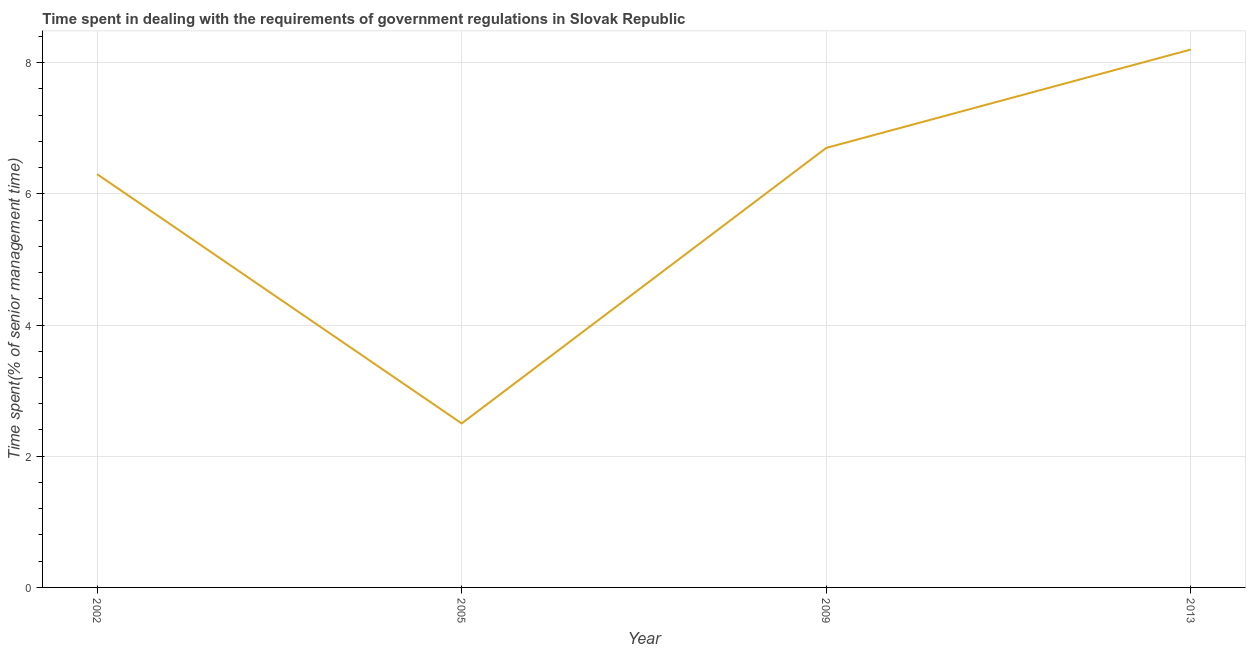What is the time spent in dealing with government regulations in 2002?
Provide a succinct answer. 6.3. Across all years, what is the maximum time spent in dealing with government regulations?
Provide a succinct answer. 8.2. What is the sum of the time spent in dealing with government regulations?
Make the answer very short. 23.7. What is the difference between the time spent in dealing with government regulations in 2002 and 2009?
Your answer should be very brief. -0.4. What is the average time spent in dealing with government regulations per year?
Keep it short and to the point. 5.92. What is the median time spent in dealing with government regulations?
Make the answer very short. 6.5. In how many years, is the time spent in dealing with government regulations greater than 0.8 %?
Give a very brief answer. 4. Do a majority of the years between 2013 and 2002 (inclusive) have time spent in dealing with government regulations greater than 2.4 %?
Provide a succinct answer. Yes. What is the ratio of the time spent in dealing with government regulations in 2002 to that in 2005?
Give a very brief answer. 2.52. Is the time spent in dealing with government regulations in 2005 less than that in 2009?
Make the answer very short. Yes. Is the difference between the time spent in dealing with government regulations in 2005 and 2009 greater than the difference between any two years?
Provide a short and direct response. No. What is the difference between the highest and the second highest time spent in dealing with government regulations?
Give a very brief answer. 1.5. What is the difference between the highest and the lowest time spent in dealing with government regulations?
Your answer should be very brief. 5.7. Does the time spent in dealing with government regulations monotonically increase over the years?
Provide a succinct answer. No. How many lines are there?
Your response must be concise. 1. How many years are there in the graph?
Offer a terse response. 4. What is the difference between two consecutive major ticks on the Y-axis?
Your answer should be compact. 2. Does the graph contain any zero values?
Ensure brevity in your answer.  No. Does the graph contain grids?
Keep it short and to the point. Yes. What is the title of the graph?
Keep it short and to the point. Time spent in dealing with the requirements of government regulations in Slovak Republic. What is the label or title of the X-axis?
Your answer should be compact. Year. What is the label or title of the Y-axis?
Offer a very short reply. Time spent(% of senior management time). What is the Time spent(% of senior management time) of 2013?
Keep it short and to the point. 8.2. What is the difference between the Time spent(% of senior management time) in 2002 and 2009?
Offer a very short reply. -0.4. What is the difference between the Time spent(% of senior management time) in 2005 and 2013?
Keep it short and to the point. -5.7. What is the ratio of the Time spent(% of senior management time) in 2002 to that in 2005?
Give a very brief answer. 2.52. What is the ratio of the Time spent(% of senior management time) in 2002 to that in 2009?
Offer a very short reply. 0.94. What is the ratio of the Time spent(% of senior management time) in 2002 to that in 2013?
Your answer should be compact. 0.77. What is the ratio of the Time spent(% of senior management time) in 2005 to that in 2009?
Your answer should be very brief. 0.37. What is the ratio of the Time spent(% of senior management time) in 2005 to that in 2013?
Your response must be concise. 0.3. What is the ratio of the Time spent(% of senior management time) in 2009 to that in 2013?
Offer a very short reply. 0.82. 